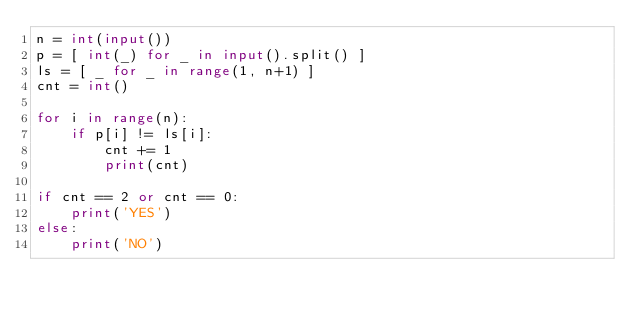<code> <loc_0><loc_0><loc_500><loc_500><_Python_>n = int(input())
p = [ int(_) for _ in input().split() ]
ls = [ _ for _ in range(1, n+1) ]
cnt = int()

for i in range(n):
    if p[i] != ls[i]:
        cnt += 1
        print(cnt)
    
if cnt == 2 or cnt == 0:
    print('YES')
else:
    print('NO')</code> 